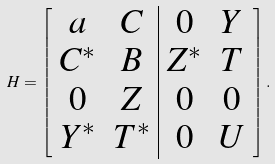Convert formula to latex. <formula><loc_0><loc_0><loc_500><loc_500>H = \left [ \begin{array} { c c | c c } a & C & 0 & Y \\ C ^ { * } & B & Z ^ { * } & T \\ 0 & Z & 0 & 0 \\ Y ^ { * } & T ^ { * } & 0 & U \end{array} \right ] .</formula> 